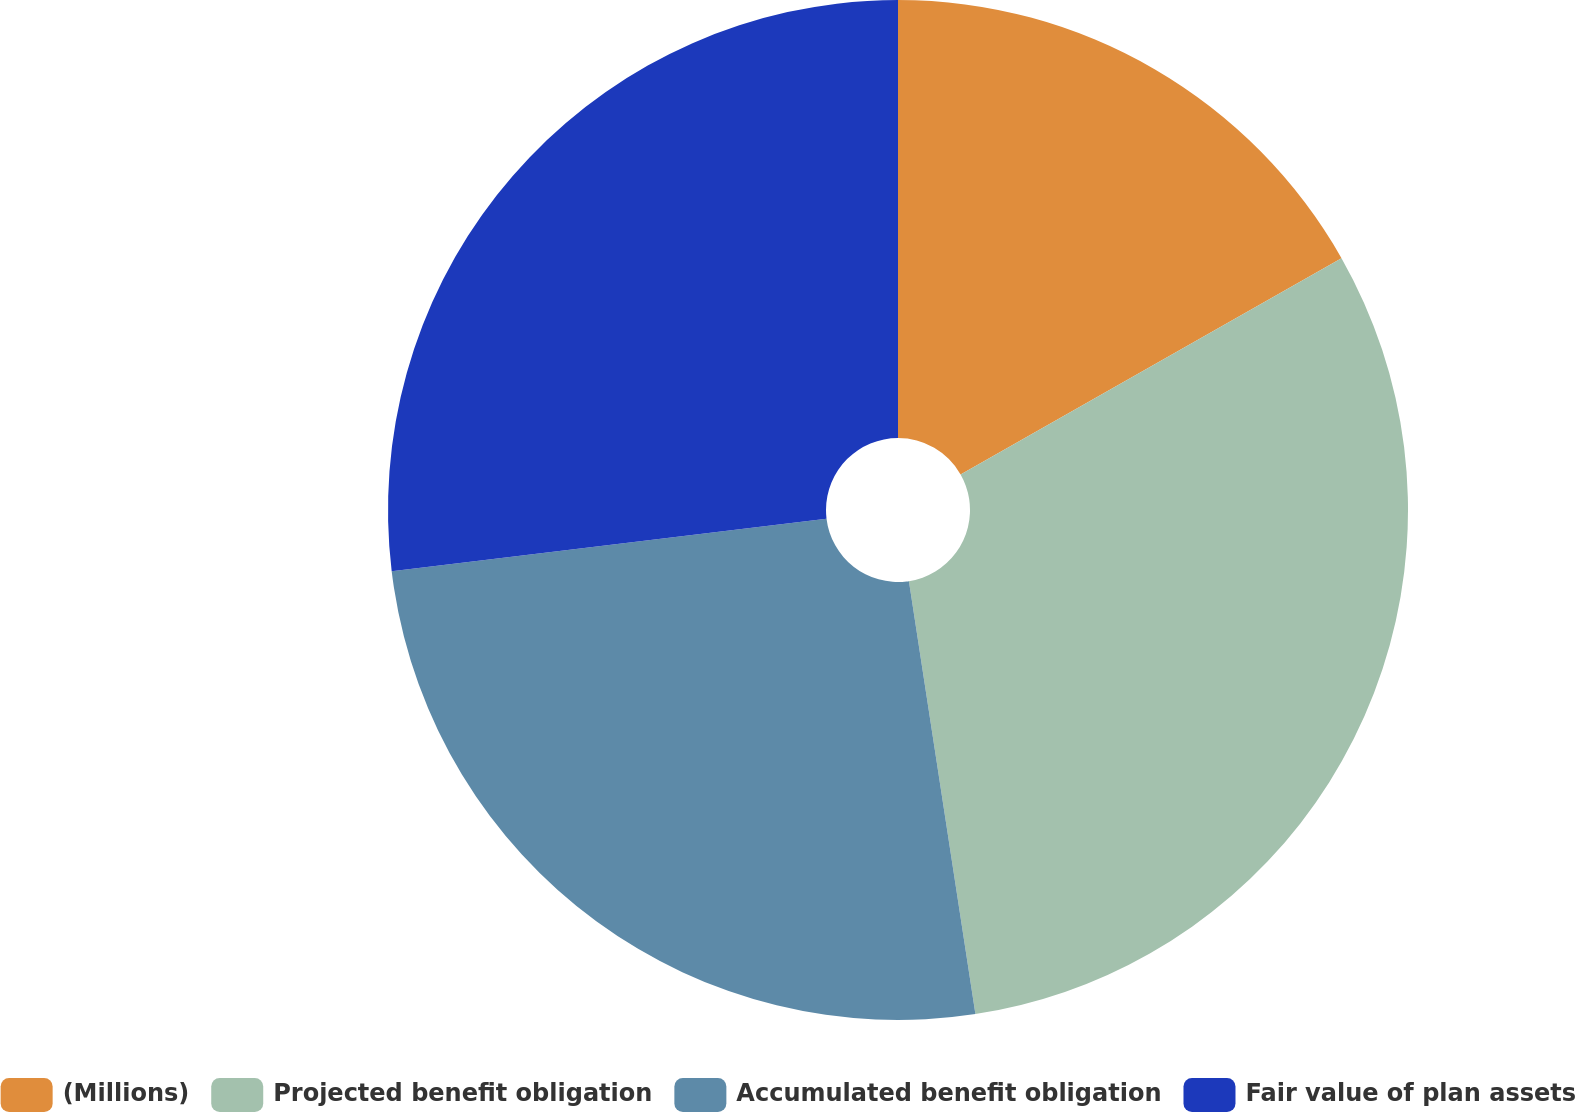Convert chart. <chart><loc_0><loc_0><loc_500><loc_500><pie_chart><fcel>(Millions)<fcel>Projected benefit obligation<fcel>Accumulated benefit obligation<fcel>Fair value of plan assets<nl><fcel>16.78%<fcel>30.79%<fcel>25.51%<fcel>26.91%<nl></chart> 